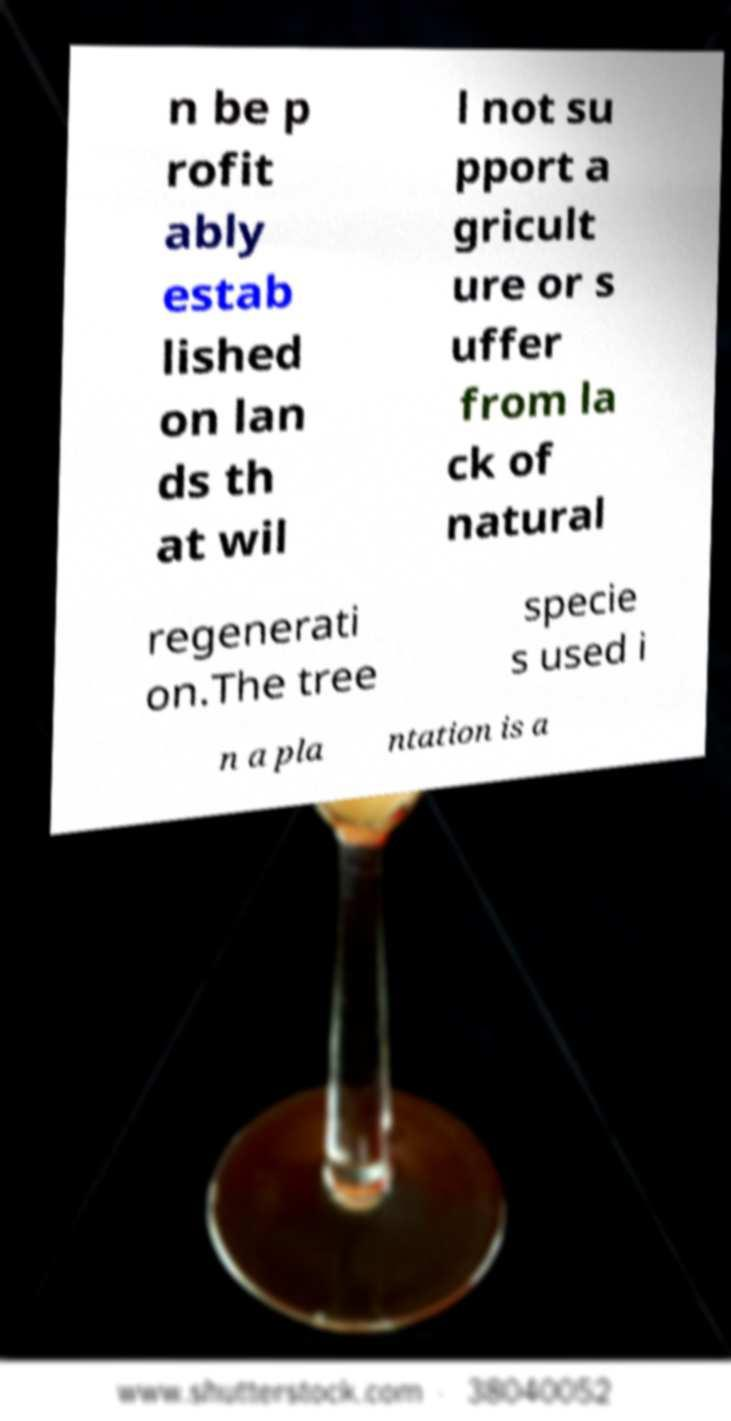Please identify and transcribe the text found in this image. n be p rofit ably estab lished on lan ds th at wil l not su pport a gricult ure or s uffer from la ck of natural regenerati on.The tree specie s used i n a pla ntation is a 